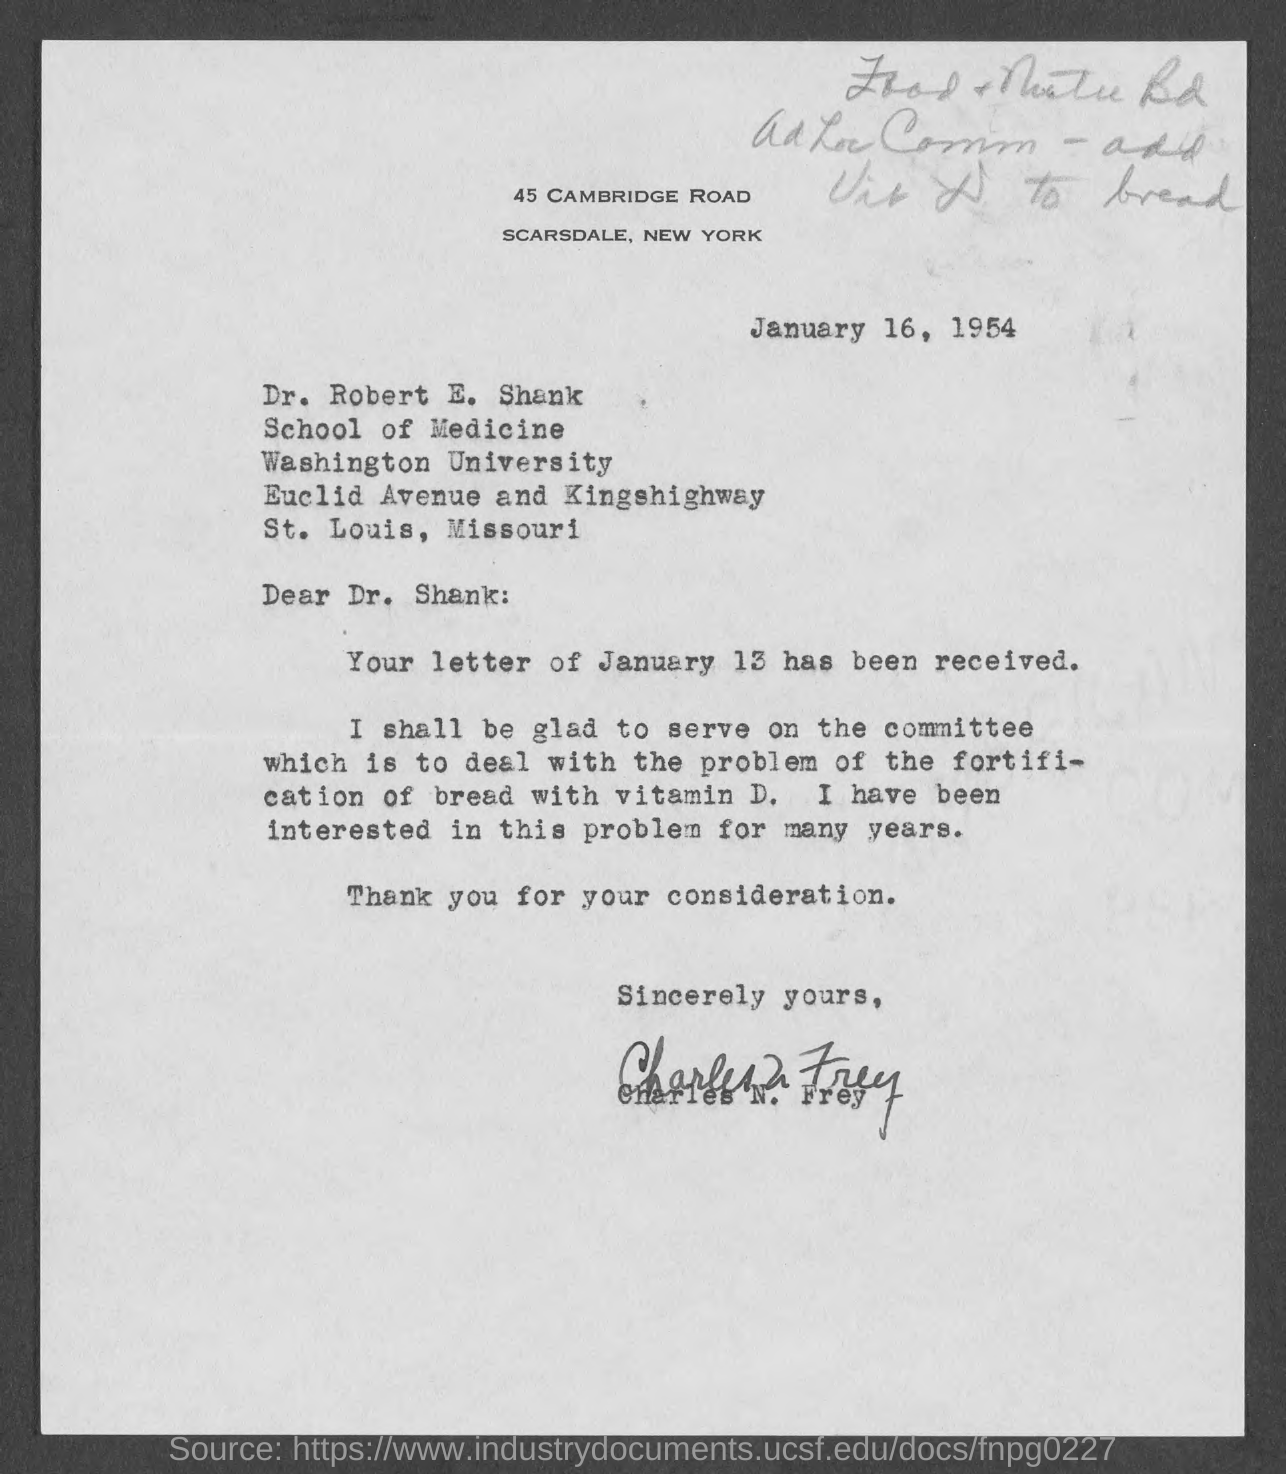What is the date?
Make the answer very short. January 16, 1954. What is the salutation of this letter?
Offer a very short reply. Dear Dr. Shank:. 